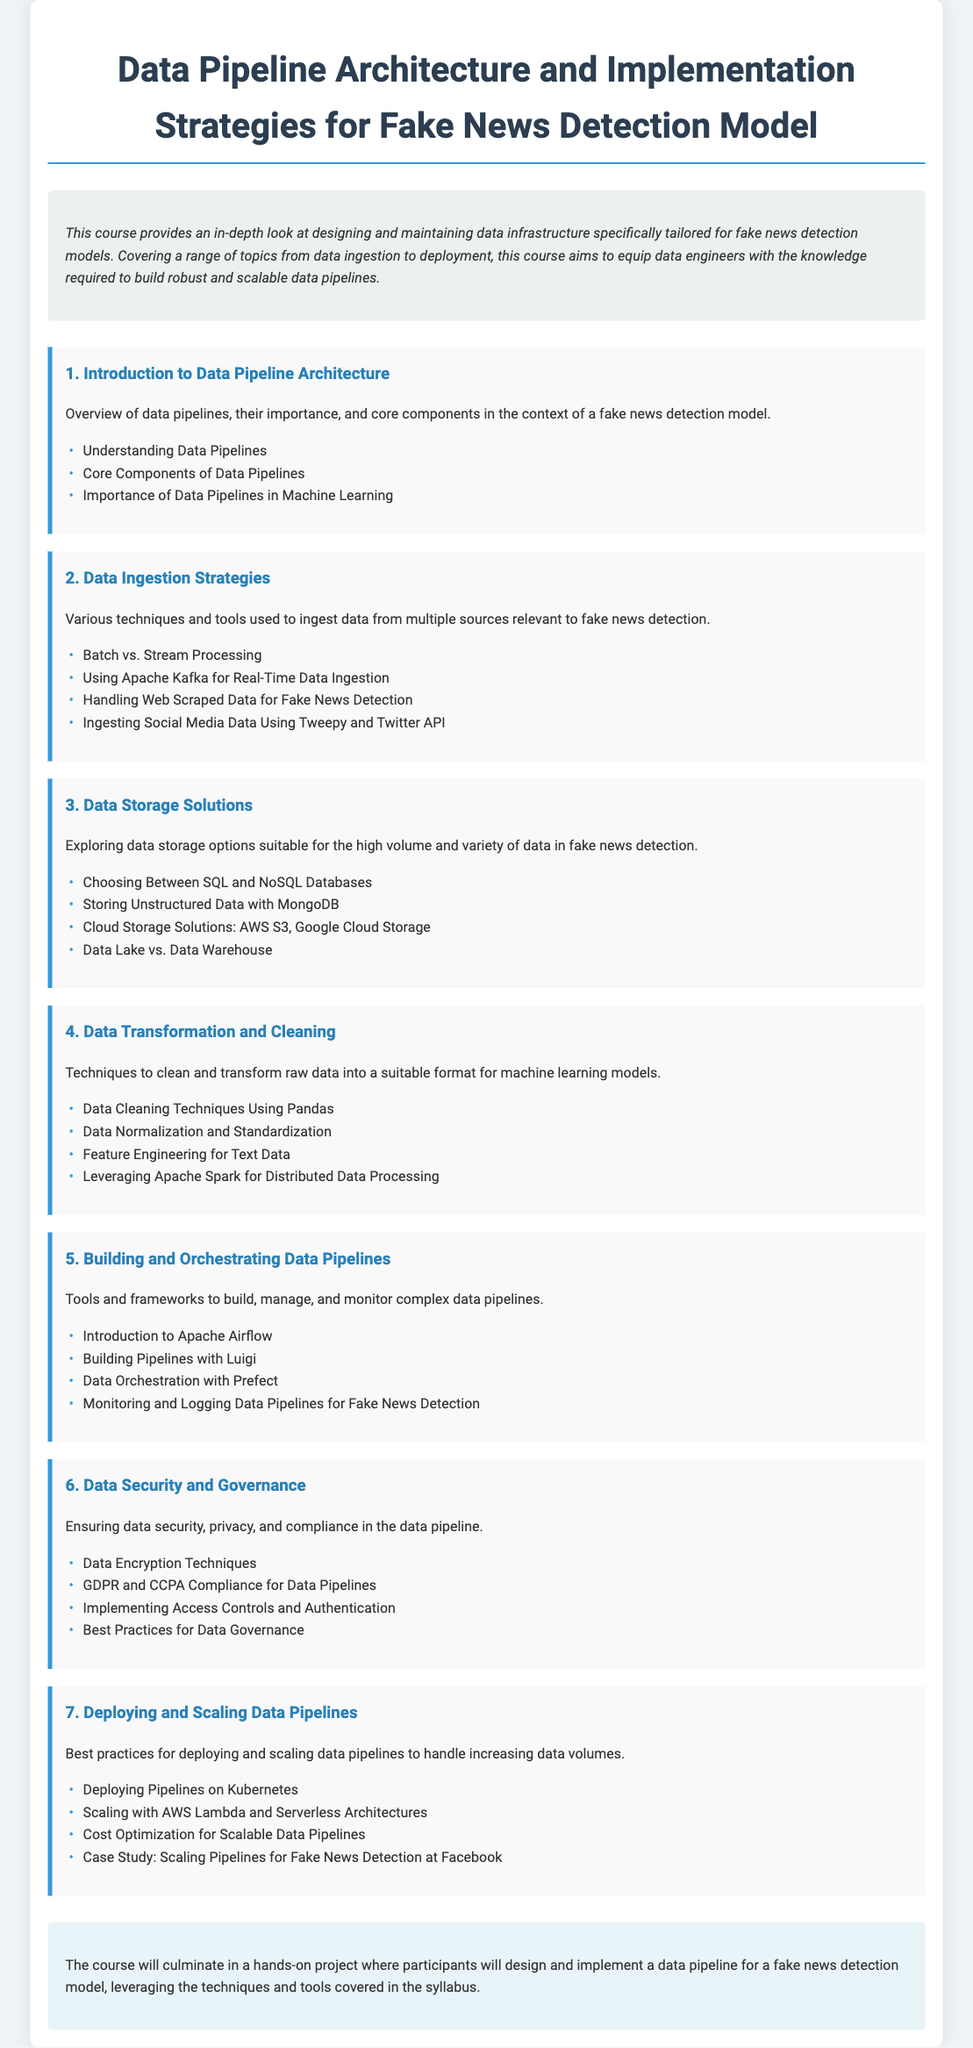What is the title of the course? The title is stated in the main heading of the document, which is prominently displayed.
Answer: Data Pipeline Architecture and Implementation Strategies for Fake News Detection Model How many modules are there in the syllabus? The number of modules is indicated by the sections each prefixed with a number, specifically the introduction to deployment strategies.
Answer: 7 What is the focus of module 4? The focus of module 4 is outlined in the description following the module title, which indicates the content covered.
Answer: Data Transformation and Cleaning Which data storage solution is shared in module 3? The solutions provided in module 3 include types of databases and cloud storage options relevant to data handling.
Answer: AWS S3, Google Cloud Storage Name a tool used for data ingestion in module 2. The specific tool mentioned in module 2 for data ingestion is indicated in the list of techniques relevant to the fake news detection model.
Answer: Apache Kafka What best practice is mentioned in module 6? The best practices are outlined under the module topics, focusing on data security and governance compliance.
Answer: Data Governance What architecture is discussed in module 7 for deploying pipelines? The architecture discussed for deployment is mentioned specifically in the context of handling scalable data volumes.
Answer: Kubernetes 